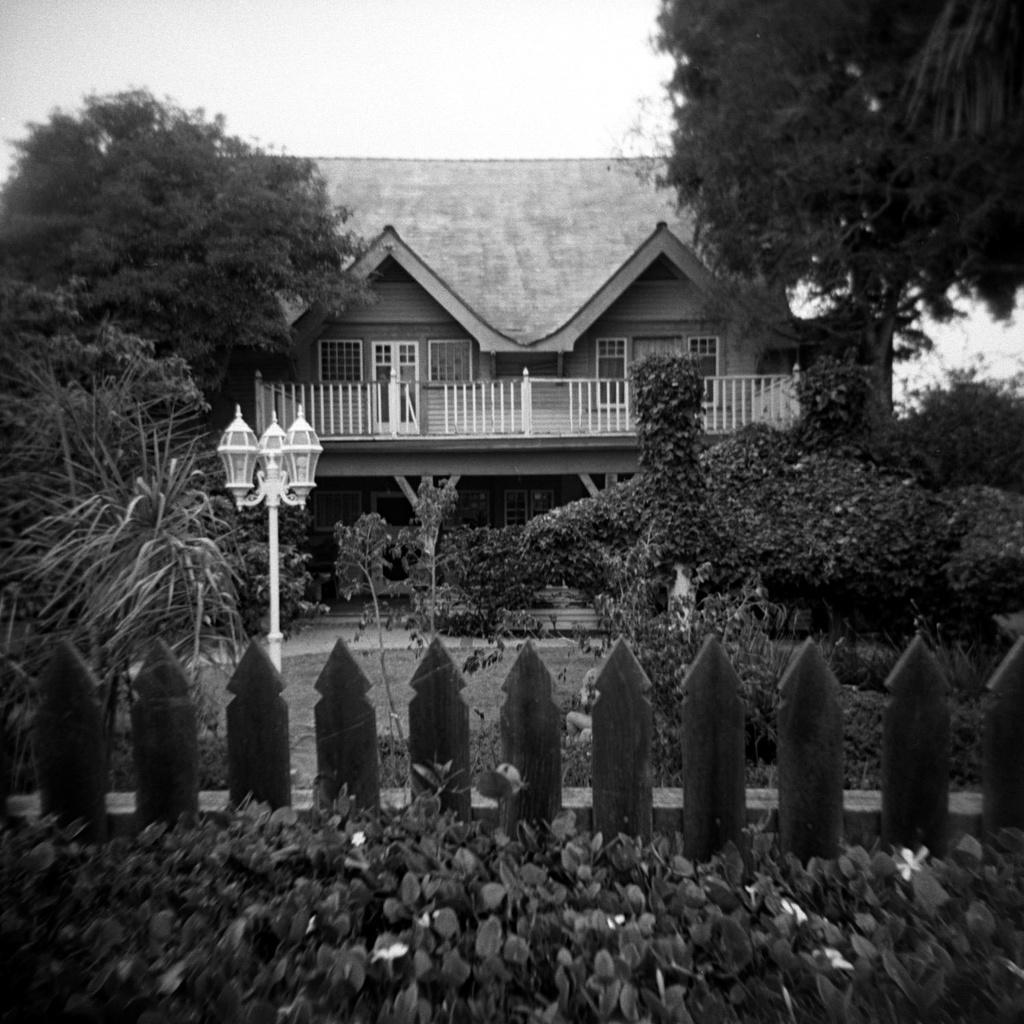What is the color scheme of the image? The image is black and white. What type of vegetation can be seen in the image? There are plants, trees, and grassy land in the image. What structures are present in the image? There is a fence, a pole, lights, a house, and a sky visible at the top of the image. What type of humor can be seen in the image? There is no humor present in the image; it is a black and white depiction of a scene with plants, trees, grassy land, a fence, a pole, lights, and a house. Can you tell me how many worms are crawling on the fence in the image? There are no worms present in the image; it features a fence, but no worms are visible. 